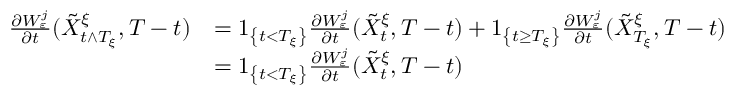<formula> <loc_0><loc_0><loc_500><loc_500>\begin{array} { r l } { \frac { \partial W _ { \varepsilon } ^ { j } } { \partial t } ( \tilde { X } _ { t \wedge T _ { \xi } } ^ { \xi } , T - t ) } & { = 1 _ { \left \{ t < T _ { \xi } \right \} } \frac { \partial W _ { \varepsilon } ^ { j } } { \partial t } ( \tilde { X } _ { t } ^ { \xi } , T - t ) + 1 _ { \left \{ t \geq T _ { \xi } \right \} } \frac { \partial W _ { \varepsilon } ^ { j } } { \partial t } ( \tilde { X } _ { T _ { \xi } } ^ { \xi } , T - t ) } \\ & { = 1 _ { \left \{ t < T _ { \xi } \right \} } \frac { \partial W _ { \varepsilon } ^ { j } } { \partial t } ( \tilde { X } _ { t } ^ { \xi } , T - t ) } \end{array}</formula> 